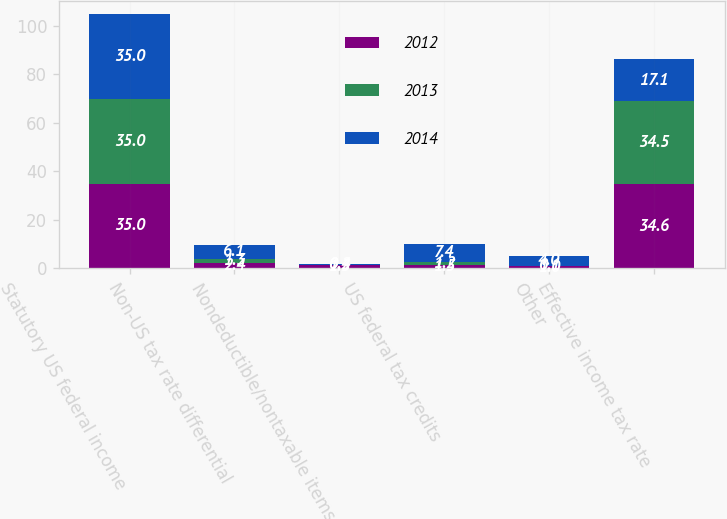Convert chart. <chart><loc_0><loc_0><loc_500><loc_500><stacked_bar_chart><ecel><fcel>Statutory US federal income<fcel>Non-US tax rate differential<fcel>Nondeductible/nontaxable items<fcel>US federal tax credits<fcel>Other<fcel>Effective income tax rate<nl><fcel>2012<fcel>35<fcel>2.4<fcel>1.3<fcel>1.5<fcel>1<fcel>34.6<nl><fcel>2013<fcel>35<fcel>1.3<fcel>0.2<fcel>1.2<fcel>0.1<fcel>34.5<nl><fcel>2014<fcel>35<fcel>6.1<fcel>0.4<fcel>7.4<fcel>4<fcel>17.1<nl></chart> 